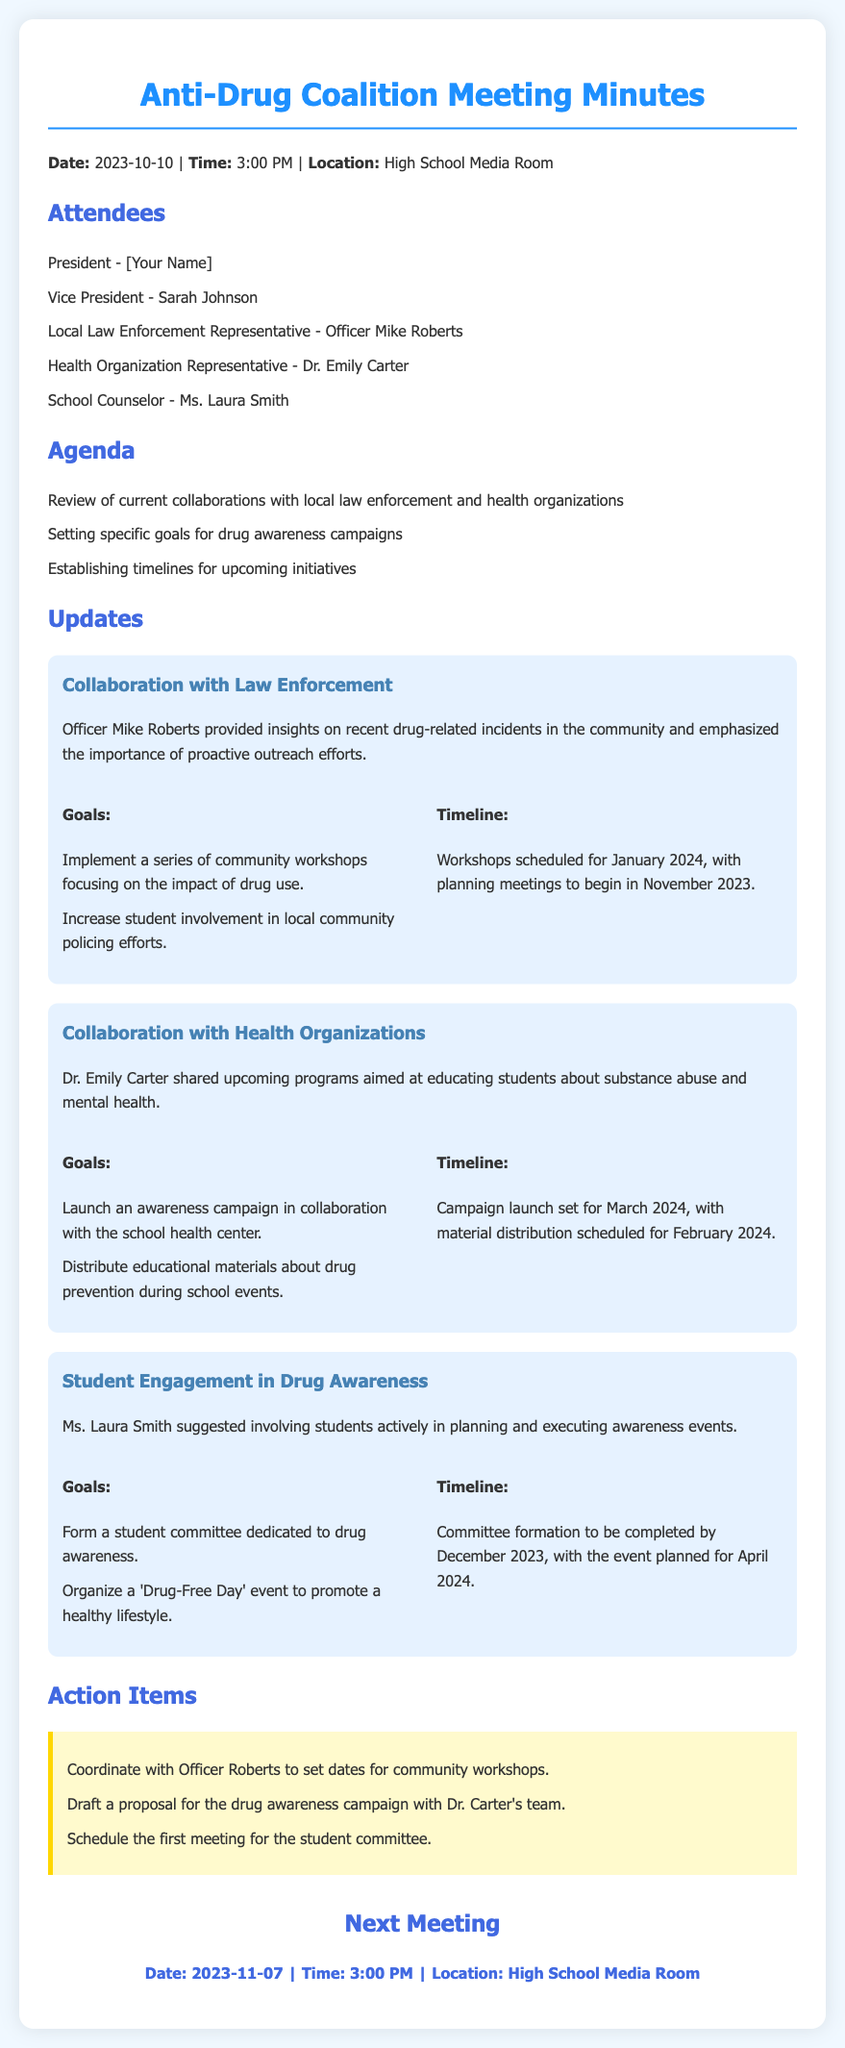What is the date of the meeting? The date of the meeting is specified in the document as 2023-10-10.
Answer: 2023-10-10 Who is the Vice President of the coalition? The Vice President is listed among the attendees of the meeting as Sarah Johnson.
Answer: Sarah Johnson What is one goal of the collaboration with law enforcement? The document mentions implementing community workshops focusing on the impact of drug use as a goal.
Answer: Implement a series of community workshops When are the community workshops scheduled to begin? The timeline indicates that planning meetings for the workshops will begin in November 2023.
Answer: November 2023 What is the name of the health organization representative? Dr. Emily Carter is identified as the health organization representative in the meeting notes.
Answer: Dr. Emily Carter What is the planned month for the awareness campaign launch? The timeline indicates that the launch for the awareness campaign is set for March 2024.
Answer: March 2024 How often will the coalition meet? The "Next Meeting" section specifies the coalition's next meeting date, which is monthly.
Answer: Monthly What is the main focus of the upcoming ‘Drug-Free Day’ event? The event's main focus, as stated in the goals, is to promote a healthy lifestyle.
Answer: Promote a healthy lifestyle When is the ‘Drug-Free Day’ event planned? The event is planned for April 2024, according to the timeline.
Answer: April 2024 